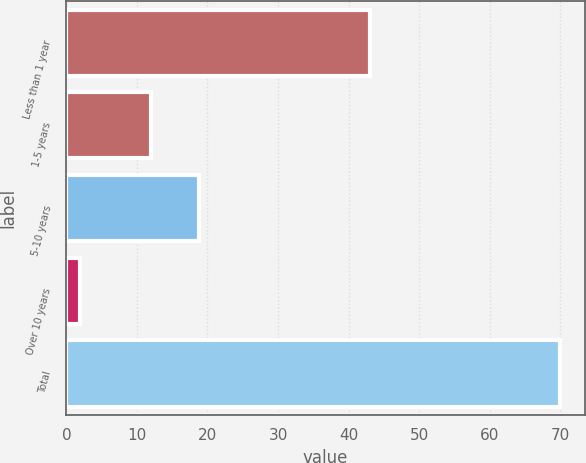Convert chart to OTSL. <chart><loc_0><loc_0><loc_500><loc_500><bar_chart><fcel>Less than 1 year<fcel>1-5 years<fcel>5-10 years<fcel>Over 10 years<fcel>Total<nl><fcel>43<fcel>12<fcel>18.8<fcel>2<fcel>70<nl></chart> 